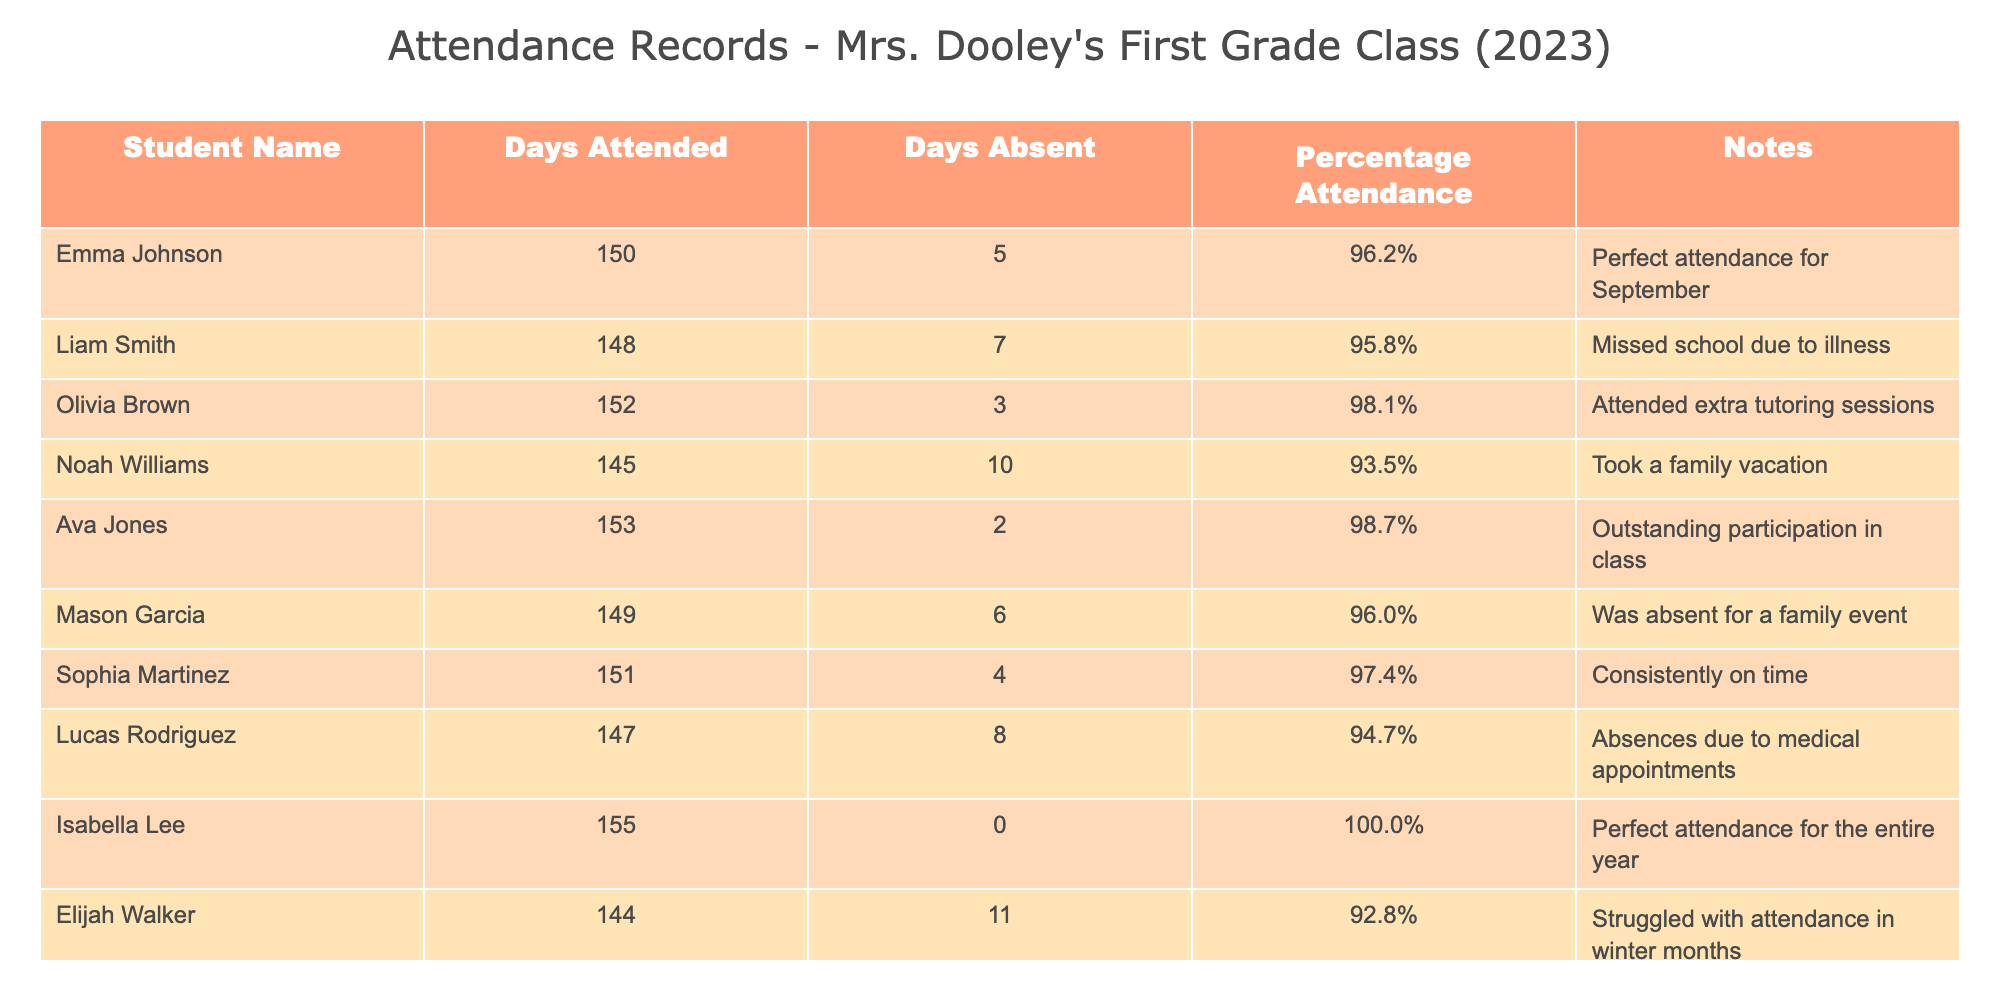What is the highest percentage attendance among the students? Looking through the "Percentage Attendance" column, Isabella Lee has the highest attendance at 100.0%.
Answer: 100.0% How many days did Noah Williams attend school? By referring to the "Days Attended" column, Noah Williams is recorded as having attended 145 days.
Answer: 145 How many total days were absent for the entire class? To find the total absent days, sum the "Days Absent" column: 5 + 7 + 3 + 10 + 2 + 6 + 4 + 8 + 0 + 11 = 56 days absent in total.
Answer: 56 Is Olivia Brown's attendance higher than the average attendance for the class? First, calculate the average attendance: total days attended is 150 + 148 + 152 + 145 + 153 + 149 + 151 + 147 + 155 + 144 = 1490 days. There are 10 students, so average = 1490/10 = 149.0 days. Olivia Brown attended 152 days, which is higher than 149.0 days.
Answer: Yes Did any student have perfect attendance for the entire year? By scanning the "Notes" column, it can be seen that Isabella Lee had perfect attendance noted as 100.0%.
Answer: Yes What is the difference in attendance days between the student with the most attendance and the student with the least attendance? The student with the most attendance is Isabella Lee with 155 days, and the student with the least is Elijah Walker with 144 days. The difference is 155 - 144 = 11 days.
Answer: 11 Which student had a note indicating they missed school due to illness? Checking the "Notes" column for illness mentions, Liam Smith's record states he missed school due to illness.
Answer: Liam Smith How many students attended more than 150 days? By reviewing the "Days Attended" column, the students who attended more than 150 days are Olivia Brown (152), Ava Jones (153), and Isabella Lee (155). This totals to 3 students.
Answer: 3 Was there a student who had more than 10 days absent? Looking at the "Days Absent" column, only Elijah Walker had 11 days absent, confirming yes to the question.
Answer: Yes 